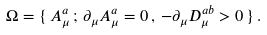<formula> <loc_0><loc_0><loc_500><loc_500>\Omega = \{ \, A ^ { a } _ { \mu } \, ; \, \partial _ { \mu } A ^ { a } _ { \mu } = 0 \, , \, - \partial _ { \mu } D ^ { a b } _ { \mu } > 0 \, \} \, .</formula> 